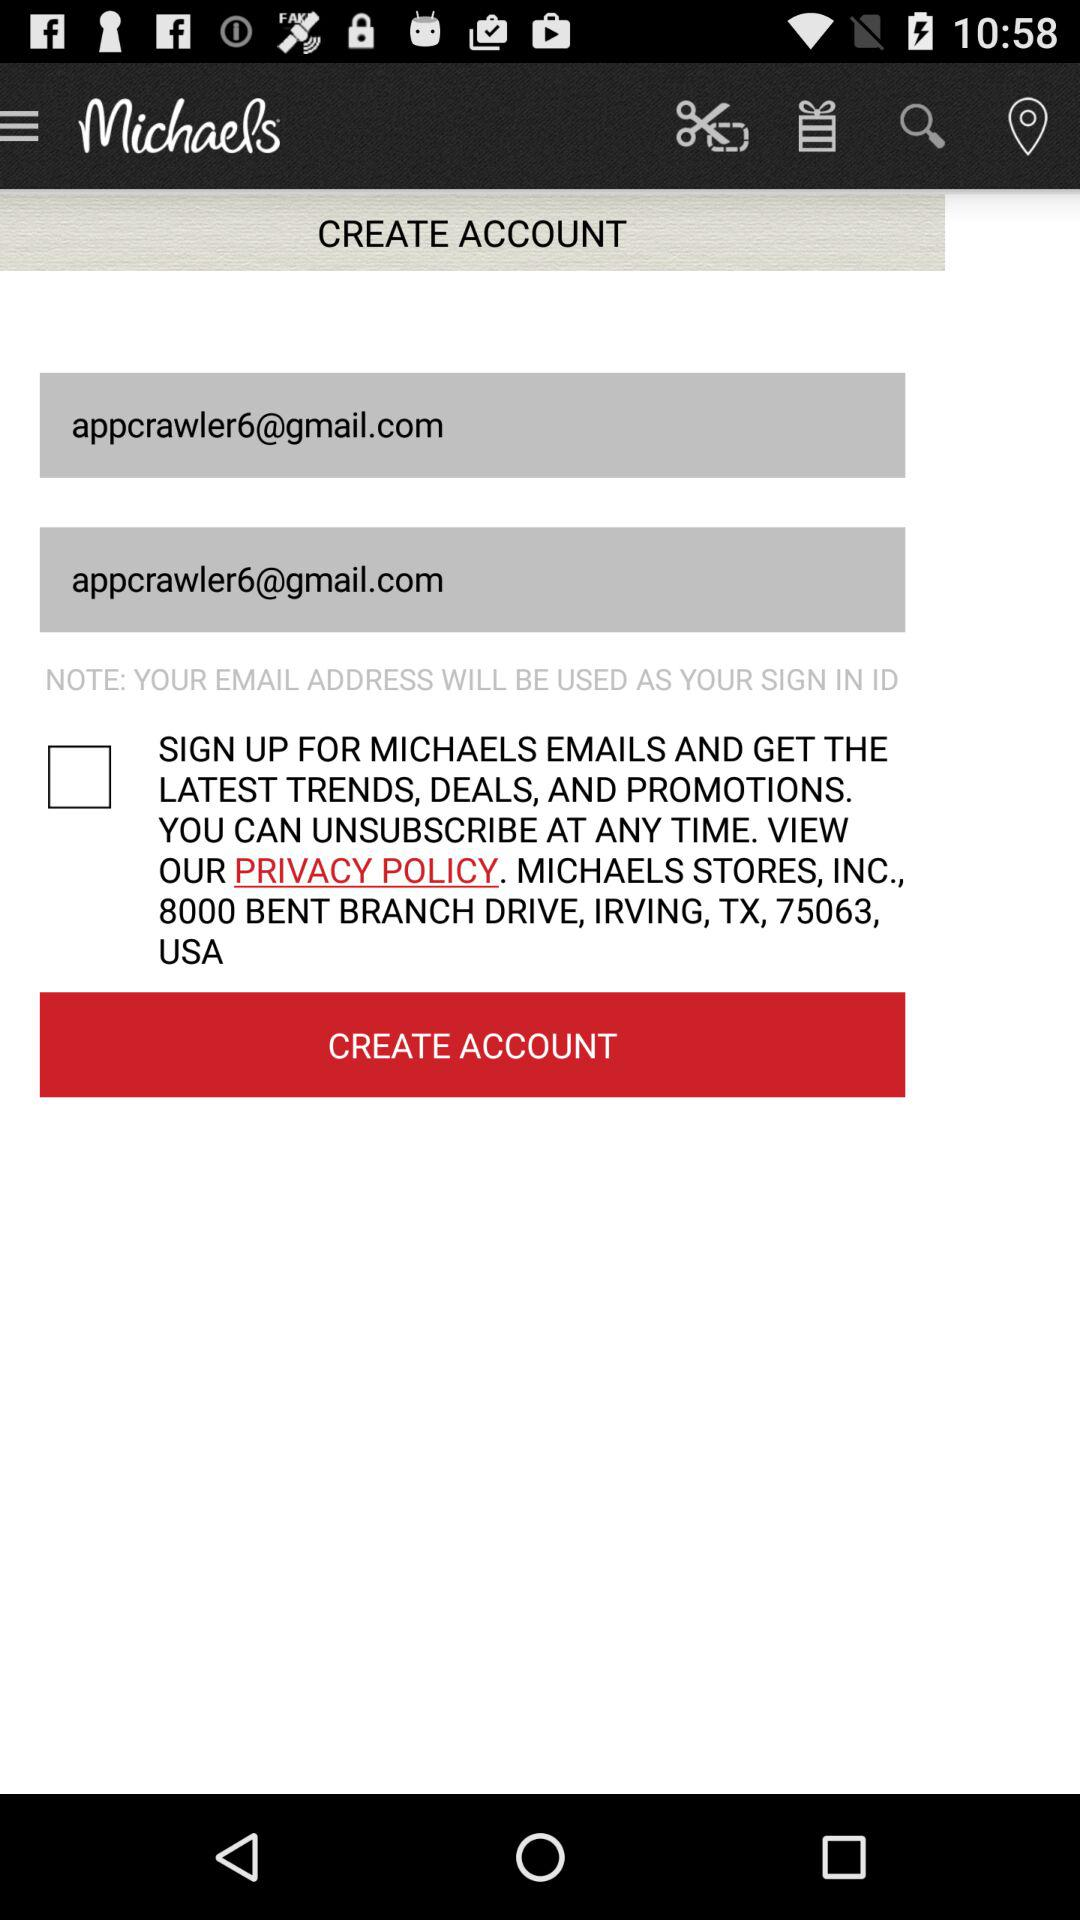What is the email address? The email address is appcrawler6@gmail.com. 